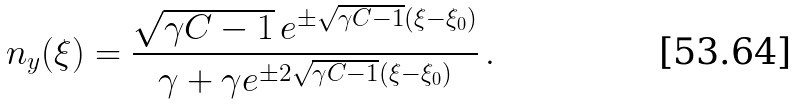<formula> <loc_0><loc_0><loc_500><loc_500>n _ { y } ( \xi ) = \frac { \sqrt { \gamma C - 1 } \, e ^ { \pm \sqrt { \gamma C - 1 } ( \xi - \xi _ { 0 } ) } } { \gamma + \gamma e ^ { \pm 2 \sqrt { \gamma C - 1 } ( \xi - \xi _ { 0 } ) } } \, .</formula> 